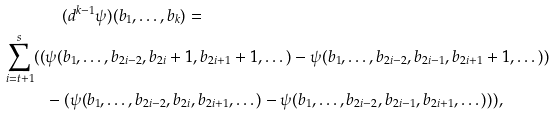Convert formula to latex. <formula><loc_0><loc_0><loc_500><loc_500>& \quad ( d ^ { k - 1 } \psi ) ( b _ { 1 } , \dots , b _ { k } ) = \\ \sum _ { i = t + 1 } ^ { s } ( ( & \psi ( b _ { 1 } , \dots , b _ { 2 i - 2 } , { b _ { 2 i } + 1 } , b _ { 2 i + 1 } + 1 , \dots ) - \psi ( b _ { 1 } , \dots , b _ { 2 i - 2 } , { b _ { 2 i - 1 } } , b _ { 2 i + 1 } + 1 , \dots ) ) \\ & - ( \psi ( b _ { 1 } , \dots , b _ { 2 i - 2 } , { b _ { 2 i } } , b _ { 2 i + 1 } , \dots ) - \psi ( b _ { 1 } , \dots , b _ { 2 i - 2 } , { b _ { 2 i - 1 } } , b _ { 2 i + 1 } , \dots ) ) ) ,</formula> 